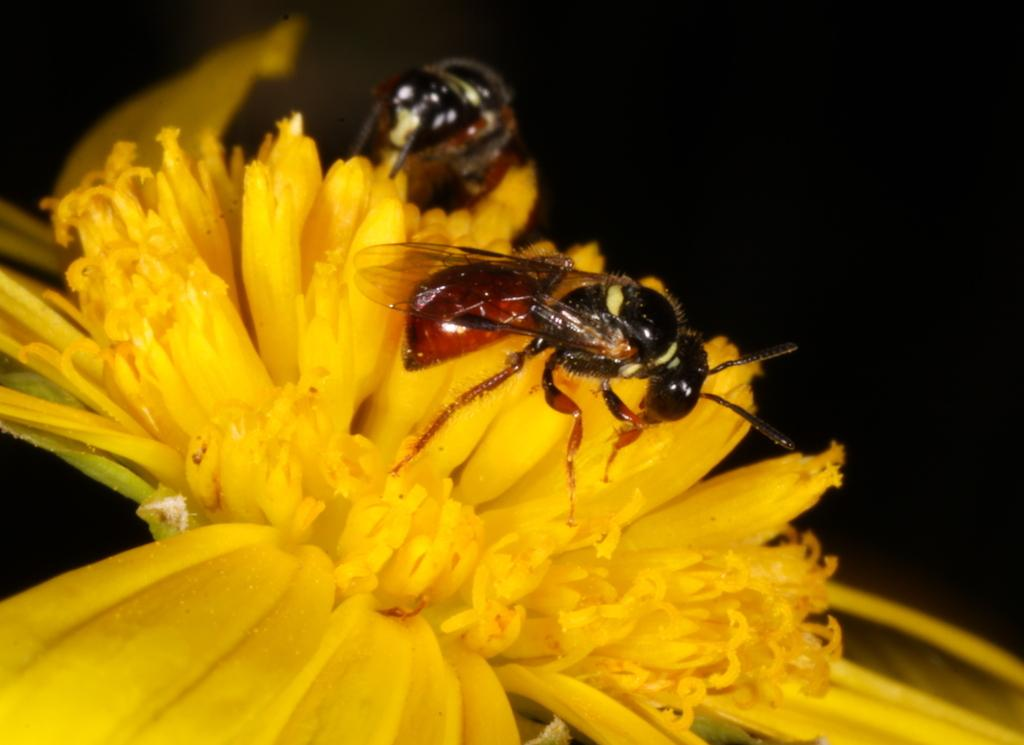What color are the flowers in the image? The flowers in the image are yellow. What can be seen on the flowers? Insects are on the flowers in the image. What color is the background of the image? The background of the image is black. What month is it in the image? The month cannot be determined from the image, as it does not contain any information about the time of year. 